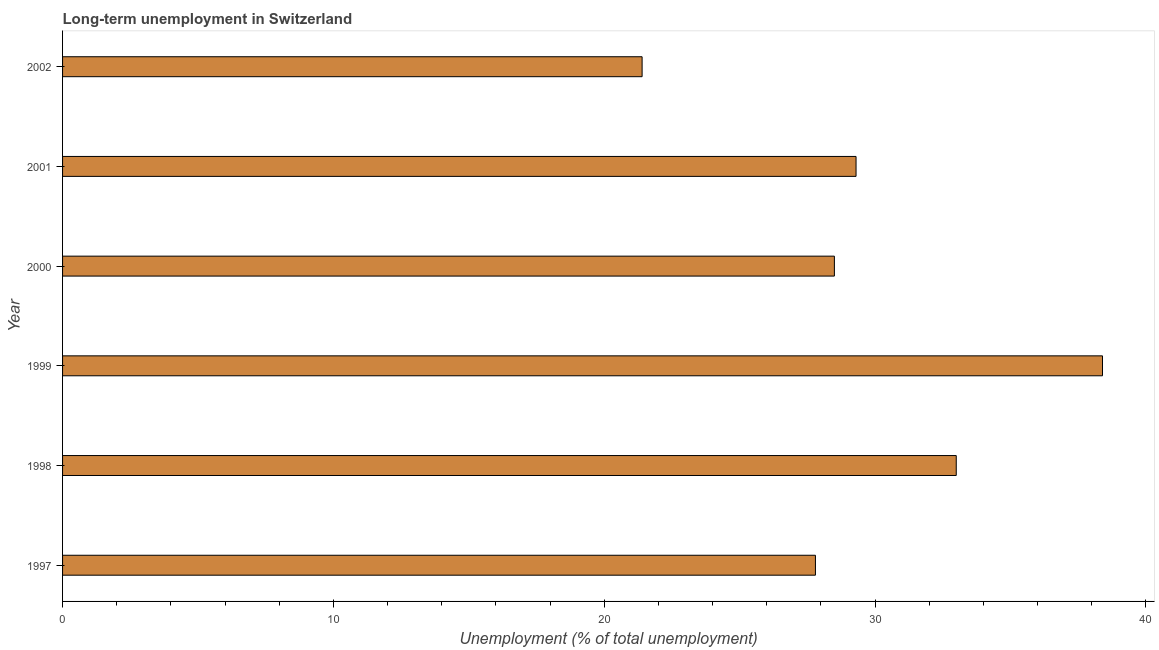Does the graph contain any zero values?
Your answer should be compact. No. What is the title of the graph?
Give a very brief answer. Long-term unemployment in Switzerland. What is the label or title of the X-axis?
Offer a terse response. Unemployment (% of total unemployment). Across all years, what is the maximum long-term unemployment?
Provide a short and direct response. 38.4. Across all years, what is the minimum long-term unemployment?
Provide a succinct answer. 21.4. In which year was the long-term unemployment minimum?
Offer a terse response. 2002. What is the sum of the long-term unemployment?
Offer a terse response. 178.4. What is the difference between the long-term unemployment in 1999 and 2001?
Make the answer very short. 9.1. What is the average long-term unemployment per year?
Give a very brief answer. 29.73. What is the median long-term unemployment?
Offer a very short reply. 28.9. Do a majority of the years between 1998 and 1997 (inclusive) have long-term unemployment greater than 36 %?
Your answer should be very brief. No. Is the long-term unemployment in 1998 less than that in 2001?
Offer a terse response. No. What is the difference between the highest and the second highest long-term unemployment?
Keep it short and to the point. 5.4. Is the sum of the long-term unemployment in 2001 and 2002 greater than the maximum long-term unemployment across all years?
Ensure brevity in your answer.  Yes. Are all the bars in the graph horizontal?
Provide a short and direct response. Yes. How many years are there in the graph?
Your response must be concise. 6. What is the difference between two consecutive major ticks on the X-axis?
Keep it short and to the point. 10. Are the values on the major ticks of X-axis written in scientific E-notation?
Ensure brevity in your answer.  No. What is the Unemployment (% of total unemployment) in 1997?
Offer a terse response. 27.8. What is the Unemployment (% of total unemployment) of 1999?
Your answer should be very brief. 38.4. What is the Unemployment (% of total unemployment) of 2001?
Give a very brief answer. 29.3. What is the Unemployment (% of total unemployment) of 2002?
Your response must be concise. 21.4. What is the difference between the Unemployment (% of total unemployment) in 1997 and 1998?
Ensure brevity in your answer.  -5.2. What is the difference between the Unemployment (% of total unemployment) in 1997 and 2001?
Make the answer very short. -1.5. What is the difference between the Unemployment (% of total unemployment) in 1997 and 2002?
Your answer should be compact. 6.4. What is the difference between the Unemployment (% of total unemployment) in 1998 and 2000?
Provide a short and direct response. 4.5. What is the difference between the Unemployment (% of total unemployment) in 1999 and 2001?
Your response must be concise. 9.1. What is the difference between the Unemployment (% of total unemployment) in 1999 and 2002?
Your answer should be very brief. 17. What is the difference between the Unemployment (% of total unemployment) in 2000 and 2002?
Provide a short and direct response. 7.1. What is the difference between the Unemployment (% of total unemployment) in 2001 and 2002?
Give a very brief answer. 7.9. What is the ratio of the Unemployment (% of total unemployment) in 1997 to that in 1998?
Keep it short and to the point. 0.84. What is the ratio of the Unemployment (% of total unemployment) in 1997 to that in 1999?
Your answer should be very brief. 0.72. What is the ratio of the Unemployment (% of total unemployment) in 1997 to that in 2001?
Your answer should be compact. 0.95. What is the ratio of the Unemployment (% of total unemployment) in 1997 to that in 2002?
Your response must be concise. 1.3. What is the ratio of the Unemployment (% of total unemployment) in 1998 to that in 1999?
Provide a short and direct response. 0.86. What is the ratio of the Unemployment (% of total unemployment) in 1998 to that in 2000?
Offer a very short reply. 1.16. What is the ratio of the Unemployment (% of total unemployment) in 1998 to that in 2001?
Your answer should be compact. 1.13. What is the ratio of the Unemployment (% of total unemployment) in 1998 to that in 2002?
Ensure brevity in your answer.  1.54. What is the ratio of the Unemployment (% of total unemployment) in 1999 to that in 2000?
Your answer should be very brief. 1.35. What is the ratio of the Unemployment (% of total unemployment) in 1999 to that in 2001?
Make the answer very short. 1.31. What is the ratio of the Unemployment (% of total unemployment) in 1999 to that in 2002?
Your answer should be compact. 1.79. What is the ratio of the Unemployment (% of total unemployment) in 2000 to that in 2001?
Keep it short and to the point. 0.97. What is the ratio of the Unemployment (% of total unemployment) in 2000 to that in 2002?
Keep it short and to the point. 1.33. What is the ratio of the Unemployment (% of total unemployment) in 2001 to that in 2002?
Offer a terse response. 1.37. 